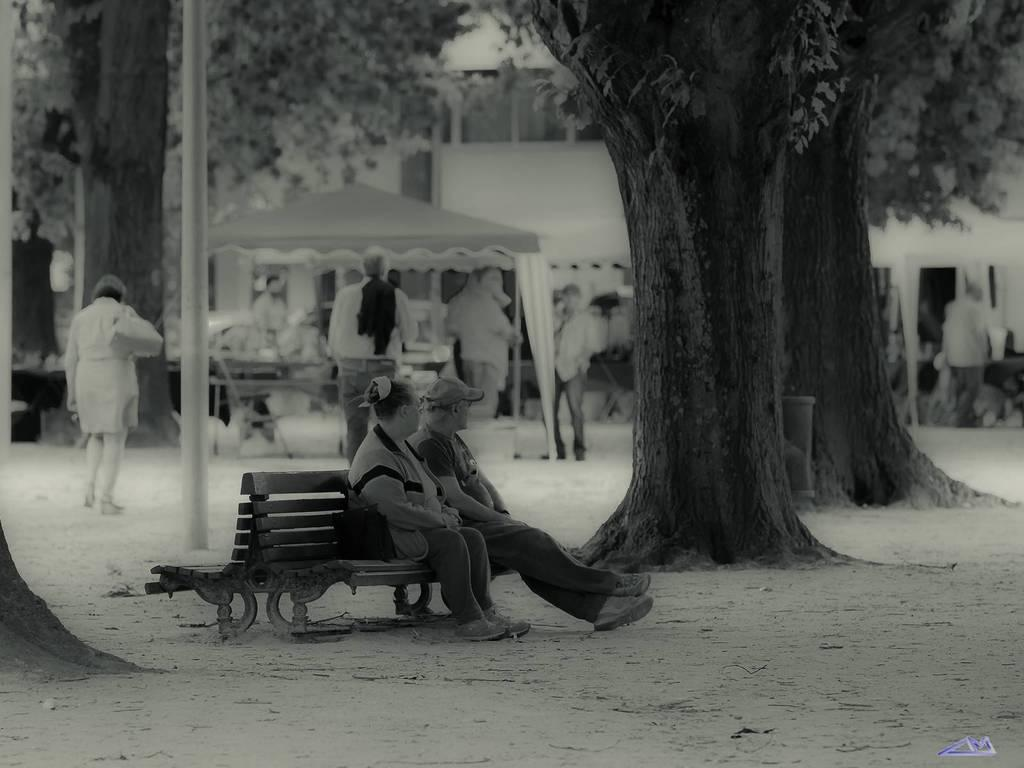What are the people in the image doing? The people in the image are sitting on benches and standing. What can be seen in the background of the image? There is a tent and a building visible in the background of the image. What type of vegetation is present in the image? Trees are present in the image. What type of goldfish can be seen swimming in the image? There are no goldfish present in the image. What is the opinion of the people sitting on the benches about the school in the image? There is no school present in the image, and therefore no opinion about it can be determined. 